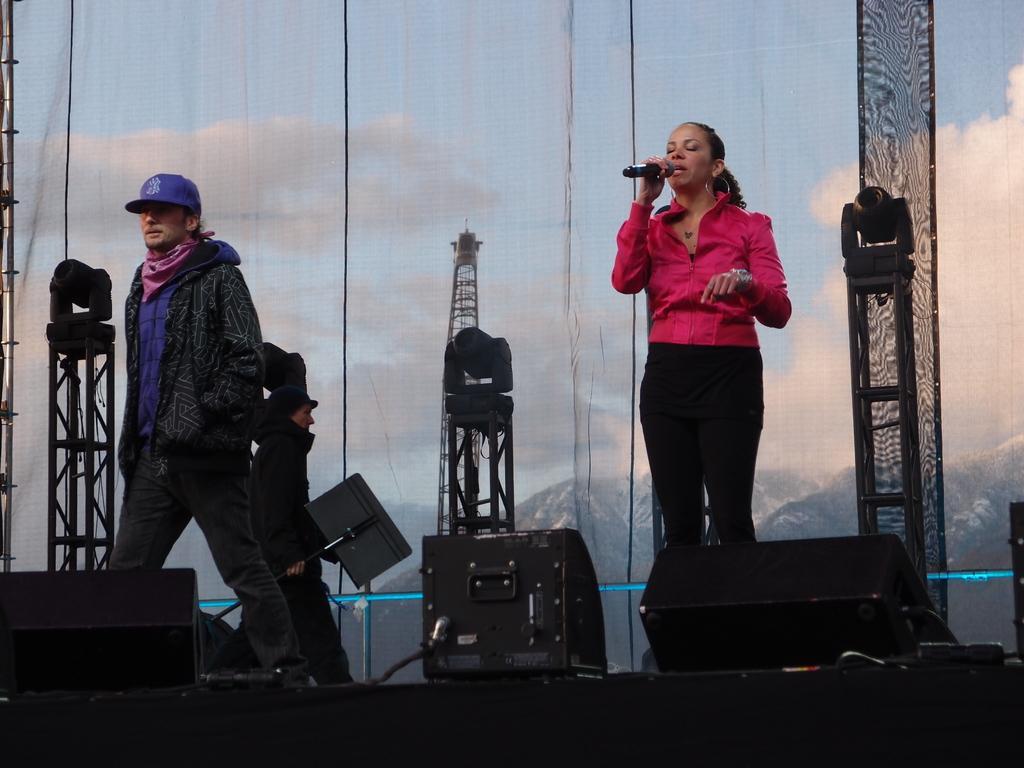Could you give a brief overview of what you see in this image? In this picture we can see group of people in the right side of the given image a woman is singing with the help of microphone and we can see some lights, sound system and stands. 